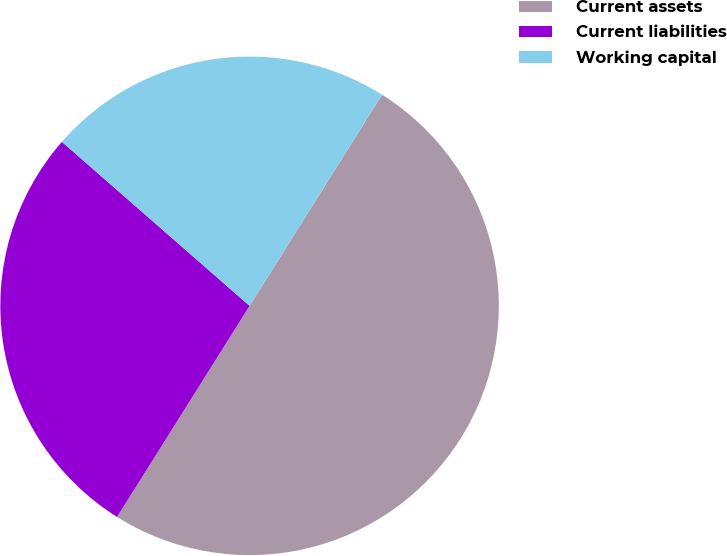Convert chart to OTSL. <chart><loc_0><loc_0><loc_500><loc_500><pie_chart><fcel>Current assets<fcel>Current liabilities<fcel>Working capital<nl><fcel>50.0%<fcel>27.51%<fcel>22.49%<nl></chart> 